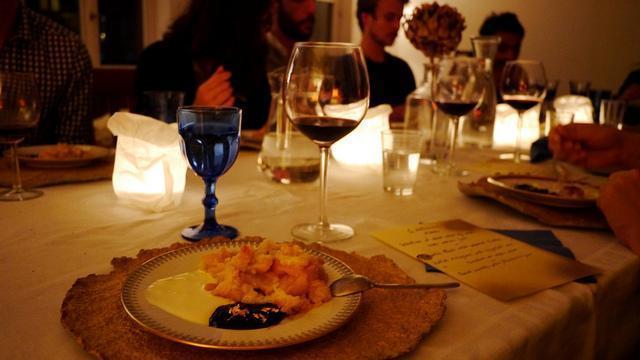How many people are in this scene?
Give a very brief answer. 5. How many red candles are there?
Give a very brief answer. 0. How many wine glasses can be seen?
Give a very brief answer. 5. How many people can be seen?
Give a very brief answer. 5. How many pink umbrellas are in this image?
Give a very brief answer. 0. 